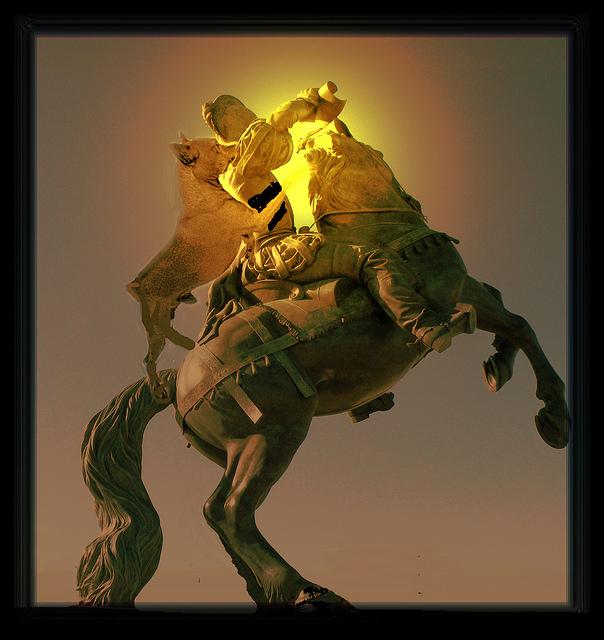What is the man riding?
Answer briefly. Horse. Is the scene a live action shot?
Write a very short answer. No. What animal is on the horse's back?
Give a very brief answer. Dog. 